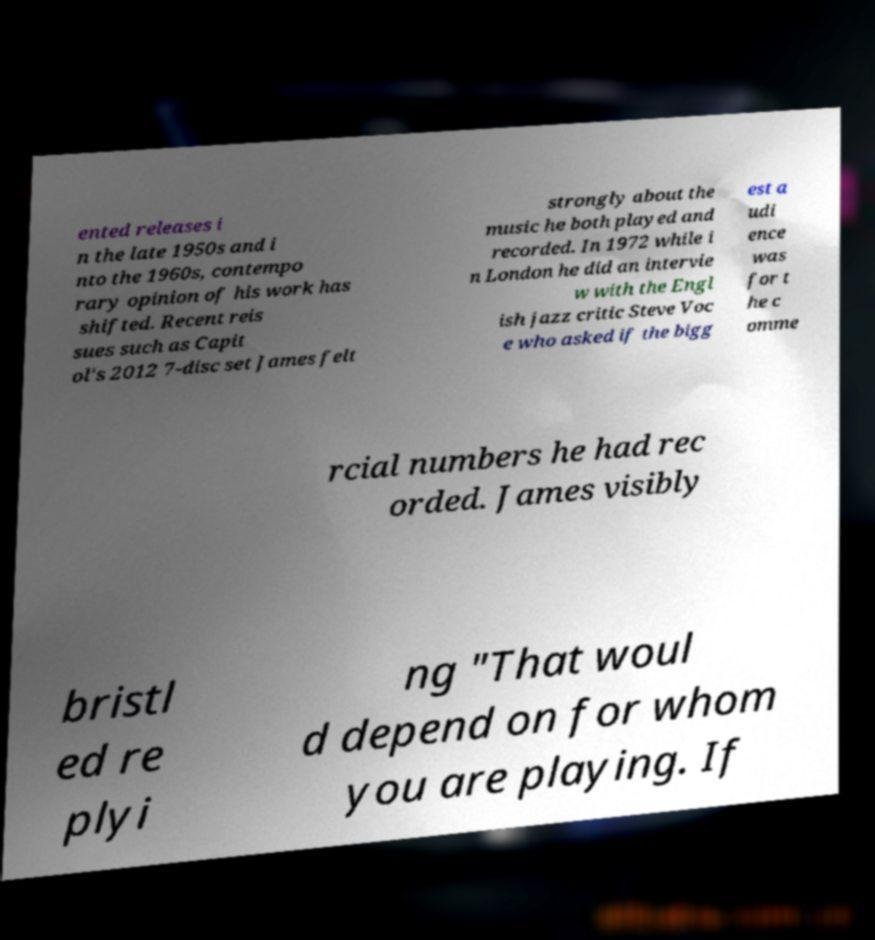For documentation purposes, I need the text within this image transcribed. Could you provide that? ented releases i n the late 1950s and i nto the 1960s, contempo rary opinion of his work has shifted. Recent reis sues such as Capit ol's 2012 7-disc set James felt strongly about the music he both played and recorded. In 1972 while i n London he did an intervie w with the Engl ish jazz critic Steve Voc e who asked if the bigg est a udi ence was for t he c omme rcial numbers he had rec orded. James visibly bristl ed re plyi ng "That woul d depend on for whom you are playing. If 